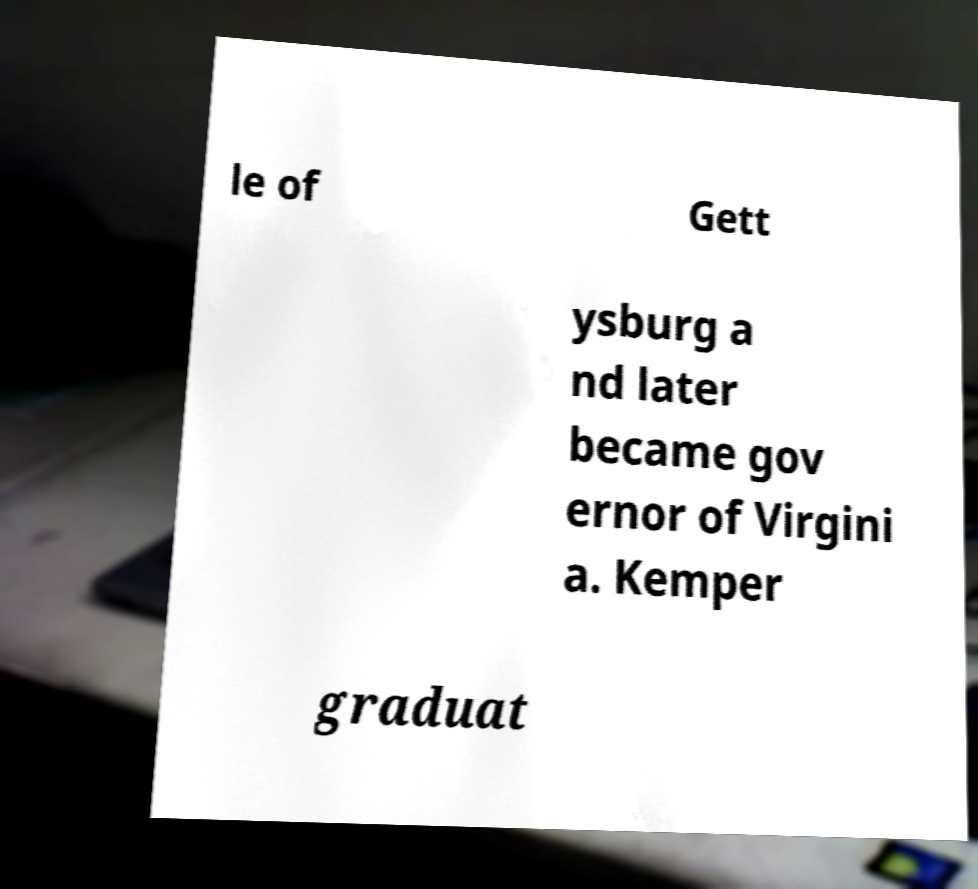Please read and relay the text visible in this image. What does it say? le of Gett ysburg a nd later became gov ernor of Virgini a. Kemper graduat 